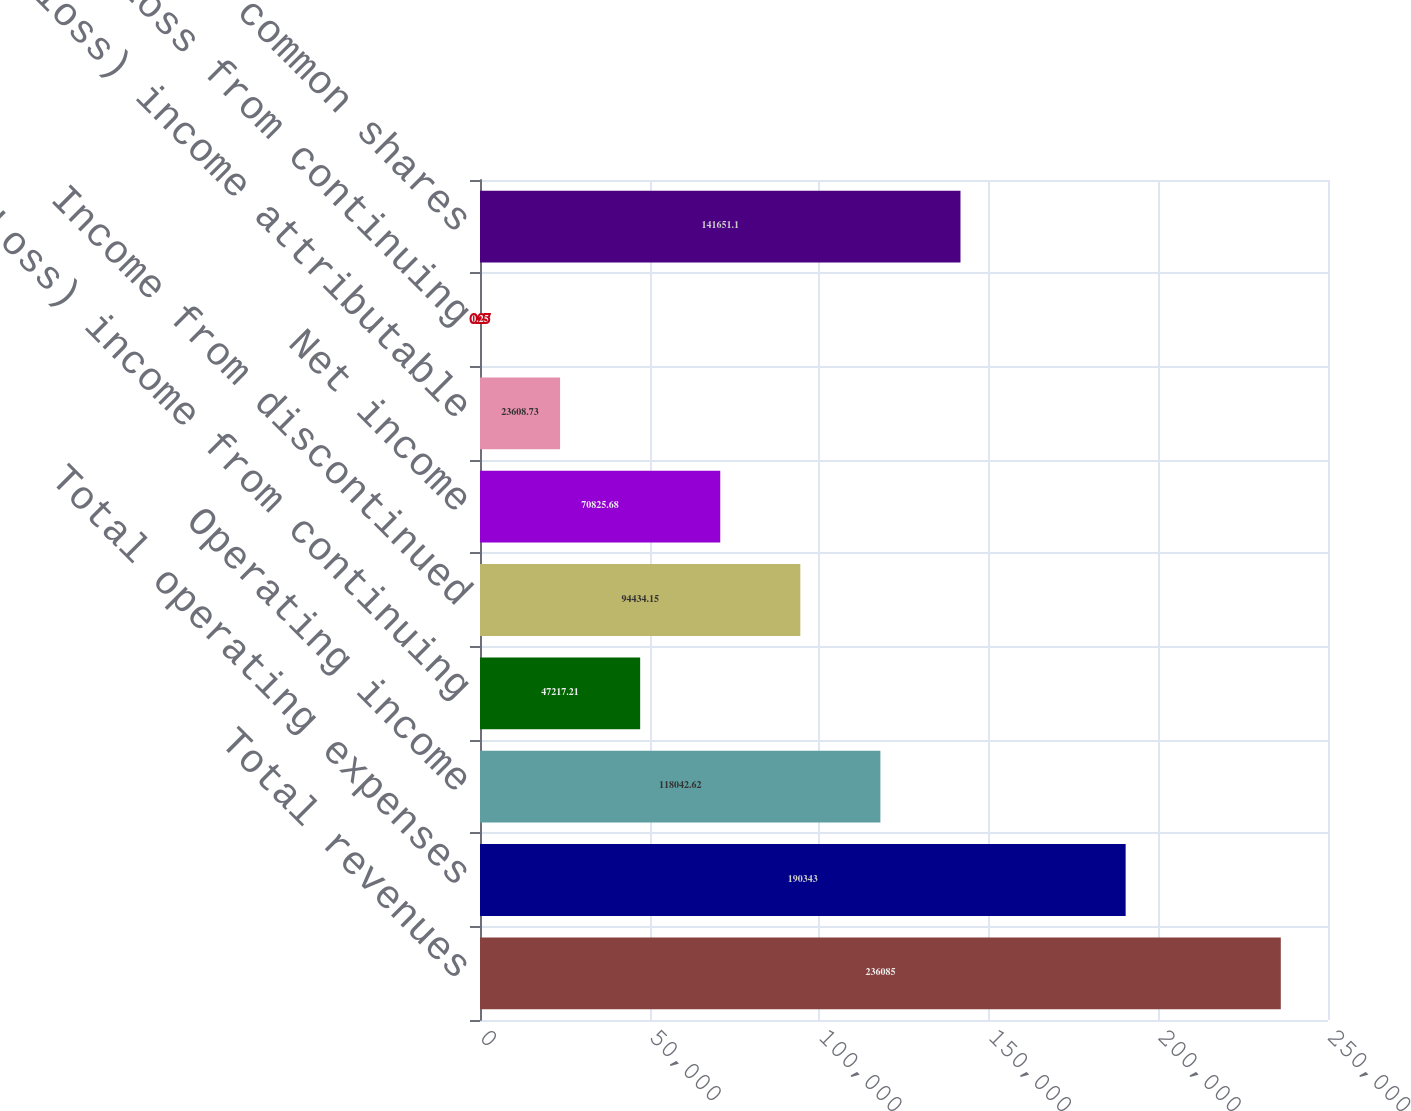<chart> <loc_0><loc_0><loc_500><loc_500><bar_chart><fcel>Total revenues<fcel>Total operating expenses<fcel>Operating income<fcel>(Loss) income from continuing<fcel>Income from discontinued<fcel>Net income<fcel>Net (loss) income attributable<fcel>Loss from continuing<fcel>Weighted average common shares<nl><fcel>236085<fcel>190343<fcel>118043<fcel>47217.2<fcel>94434.1<fcel>70825.7<fcel>23608.7<fcel>0.25<fcel>141651<nl></chart> 